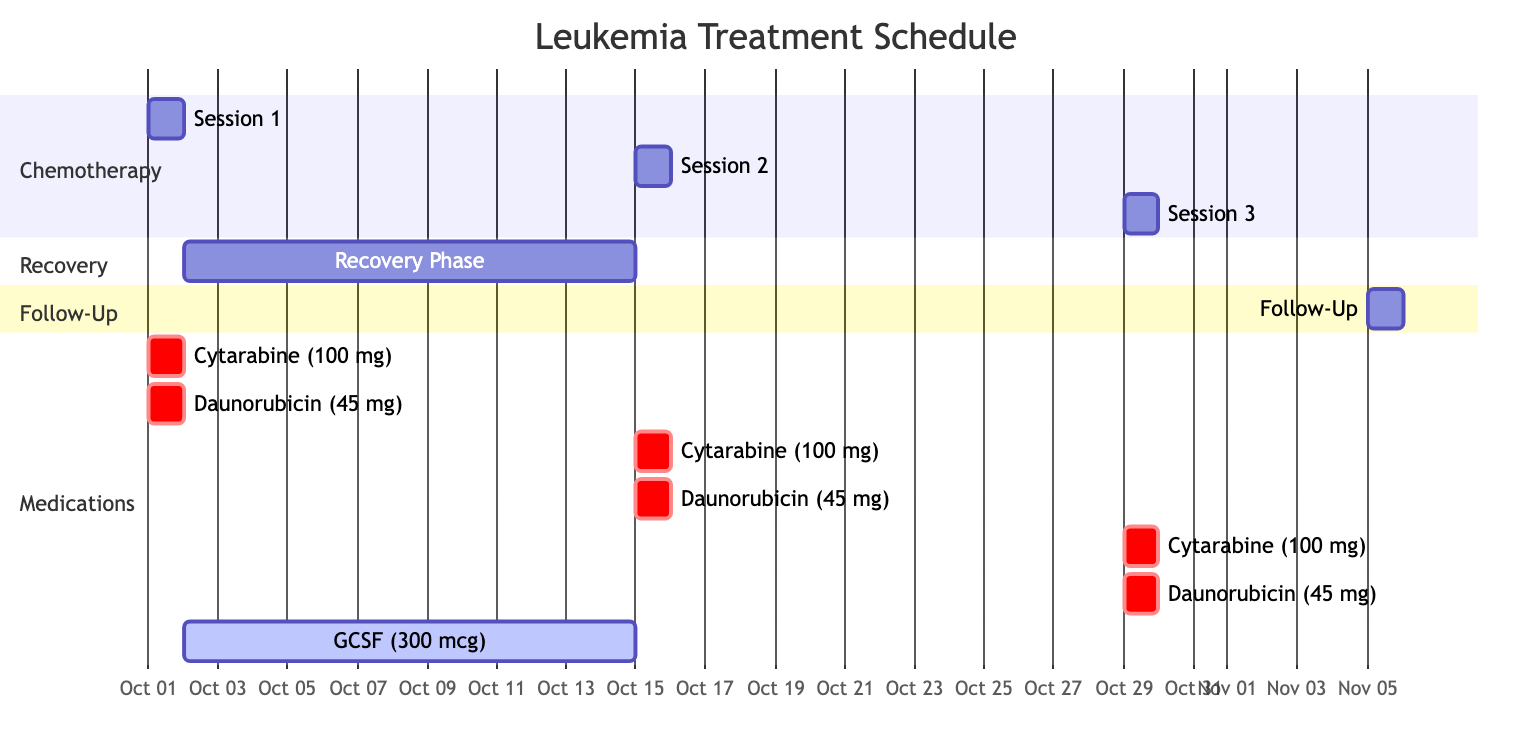What are the start and end dates of Session 1? The diagram indicates that Session 1 starts on October 1, 2023, and ends on the same date, October 1, 2023.
Answer: October 1, 2023 How many chemotherapy sessions are scheduled? Reviewing the diagram, there are three chemotherapy sessions visible: Session 1, Session 2, and Session 3.
Answer: Three What medication is administered during the Recovery Phase? The Recovery Phase section of the diagram shows that Granulocyte Colony Stimulating Factor is the medication used during this phase.
Answer: Granulocyte Colony Stimulating Factor How long is the Recovery Phase? By examining the start date of October 2, 2023, and the end date of October 14, 2023, we see that the Recovery Phase lasts for 13 days.
Answer: 13 days What medications are administered during Session 2? The diagram shows that during Session 2, both Cytarabine and Daunorubicin are given, without any other medications.
Answer: Cytarabine and Daunorubicin On which date is the Follow-Up scheduled? The Follow-Up section of the diagram clearly shows it is scheduled for November 5, 2023.
Answer: November 5, 2023 Which medication has the highest dosage in the treatment schedule? Analyzing the medications listed, Granulocyte Colony Stimulating Factor is administered at 300 mcg, which is the highest dosage compared to the others.
Answer: 300 mcg What is the duration between Session 1 and Session 2? The start date of Session 2 is October 15, 2023, and Session 1 ends on October 1, 2023. Therefore, the duration between these two sessions is 14 days.
Answer: 14 days How many total medications are given on October 1, 2023? The diagram specifies that both Cytarabine and Daunorubicin are given on October 1, 2023, totaling to two medications.
Answer: Two 